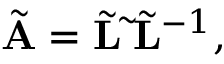<formula> <loc_0><loc_0><loc_500><loc_500>\begin{array} { r } { \tilde { A } = \tilde { L } \tilde { \Lambda } \tilde { L } ^ { - 1 } , } \end{array}</formula> 